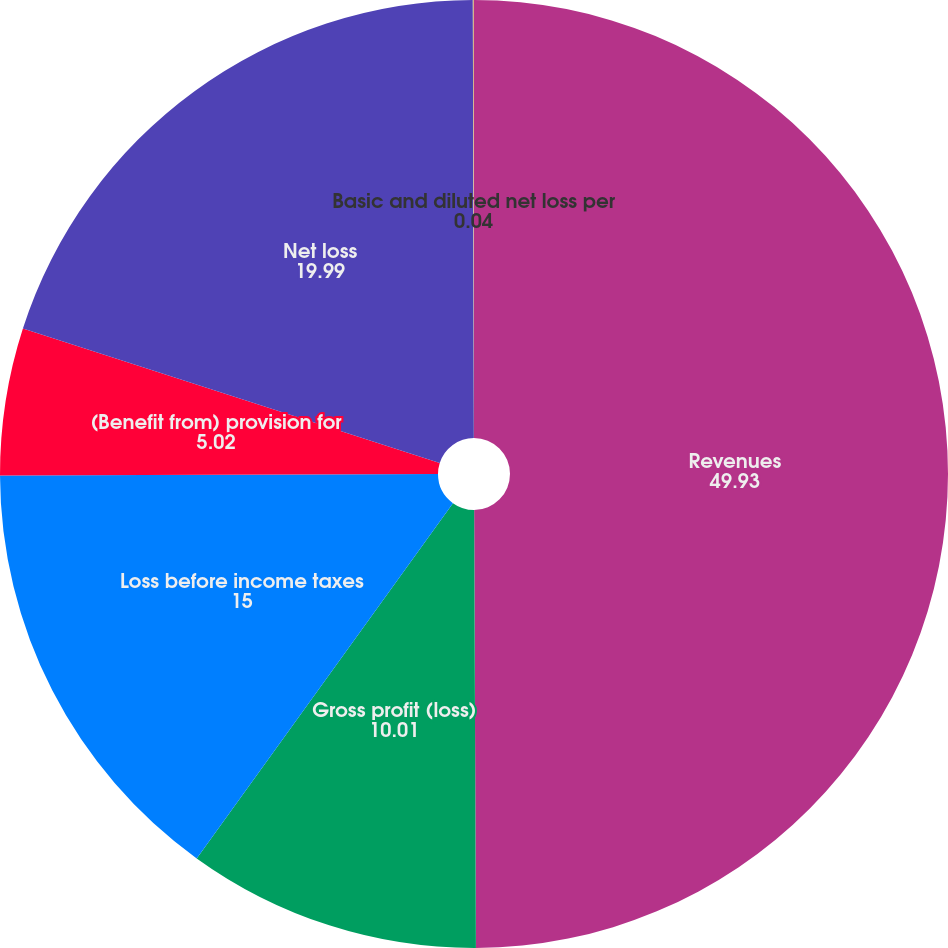Convert chart. <chart><loc_0><loc_0><loc_500><loc_500><pie_chart><fcel>Revenues<fcel>Gross profit (loss)<fcel>Loss before income taxes<fcel>(Benefit from) provision for<fcel>Net loss<fcel>Basic and diluted net loss per<nl><fcel>49.93%<fcel>10.01%<fcel>15.0%<fcel>5.02%<fcel>19.99%<fcel>0.04%<nl></chart> 